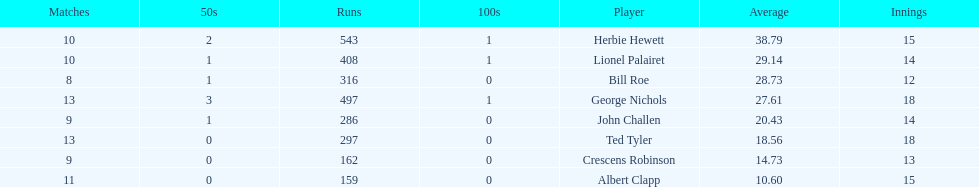Can you tell me the quantity of runs achieved by ted tyler? 297. 